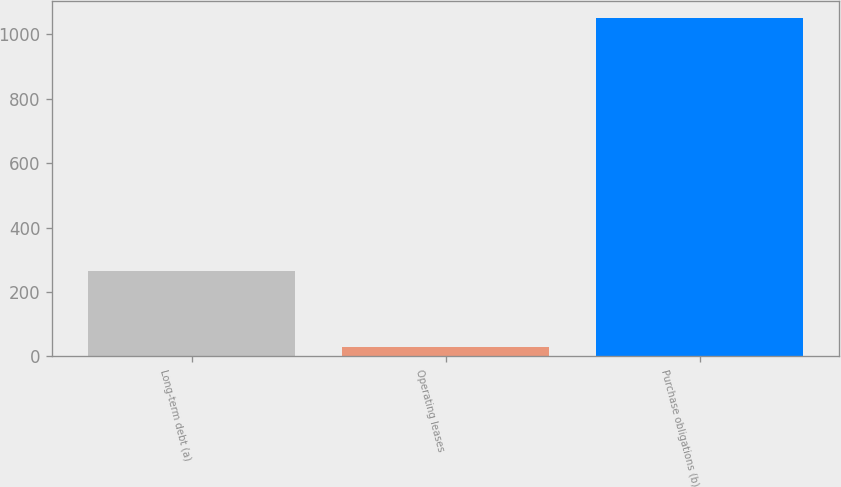Convert chart. <chart><loc_0><loc_0><loc_500><loc_500><bar_chart><fcel>Long-term debt (a)<fcel>Operating leases<fcel>Purchase obligations (b)<nl><fcel>266<fcel>29<fcel>1050<nl></chart> 